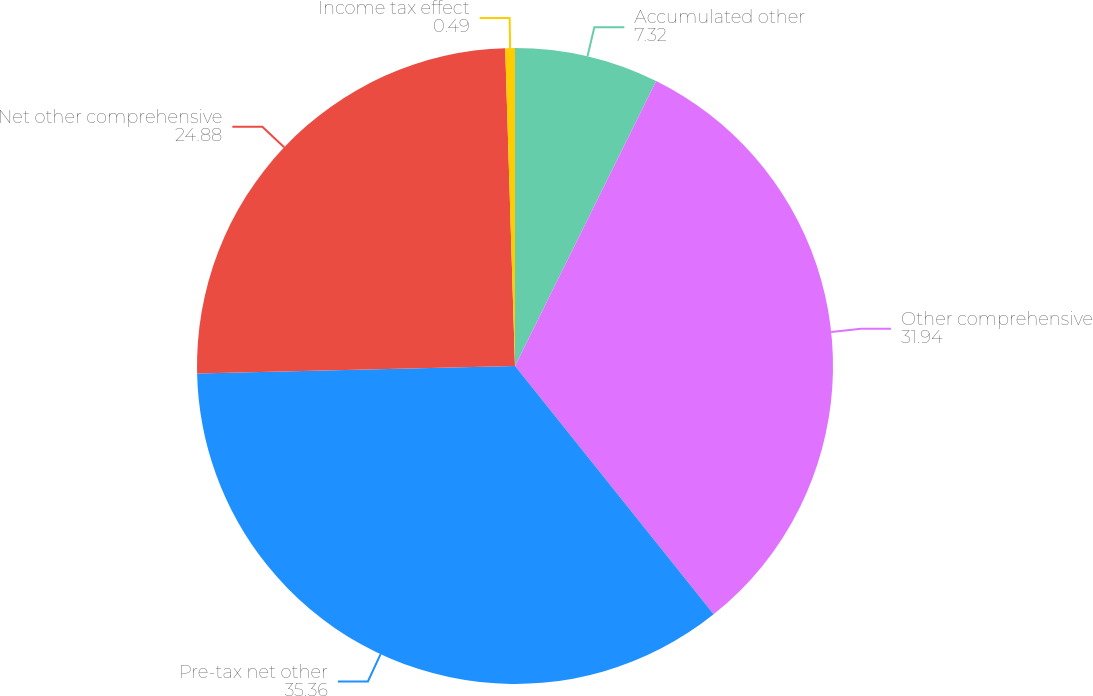<chart> <loc_0><loc_0><loc_500><loc_500><pie_chart><fcel>Accumulated other<fcel>Other comprehensive<fcel>Pre-tax net other<fcel>Net other comprehensive<fcel>Income tax effect<nl><fcel>7.32%<fcel>31.94%<fcel>35.36%<fcel>24.88%<fcel>0.49%<nl></chart> 